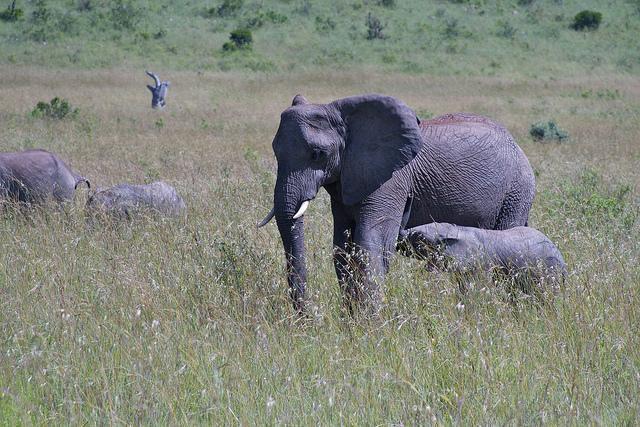What is the sharpest item here?
Make your selection from the four choices given to correctly answer the question.
Options: Scissors, unicorn horn, tusks, machete. Tusks. 